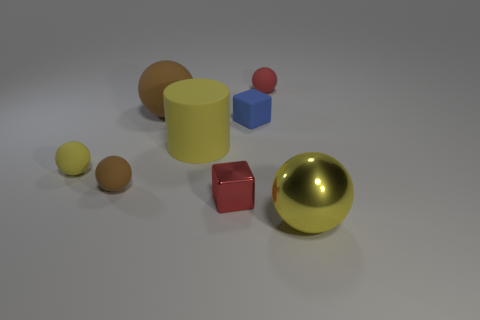Subtract all brown spheres. How many spheres are left? 3 Subtract all yellow metal spheres. How many spheres are left? 4 Add 1 brown rubber objects. How many objects exist? 9 Subtract all cyan spheres. Subtract all green cylinders. How many spheres are left? 5 Subtract all cylinders. How many objects are left? 7 Add 4 large blocks. How many large blocks exist? 4 Subtract 0 brown cubes. How many objects are left? 8 Subtract all tiny red objects. Subtract all tiny brown spheres. How many objects are left? 5 Add 1 big matte things. How many big matte things are left? 3 